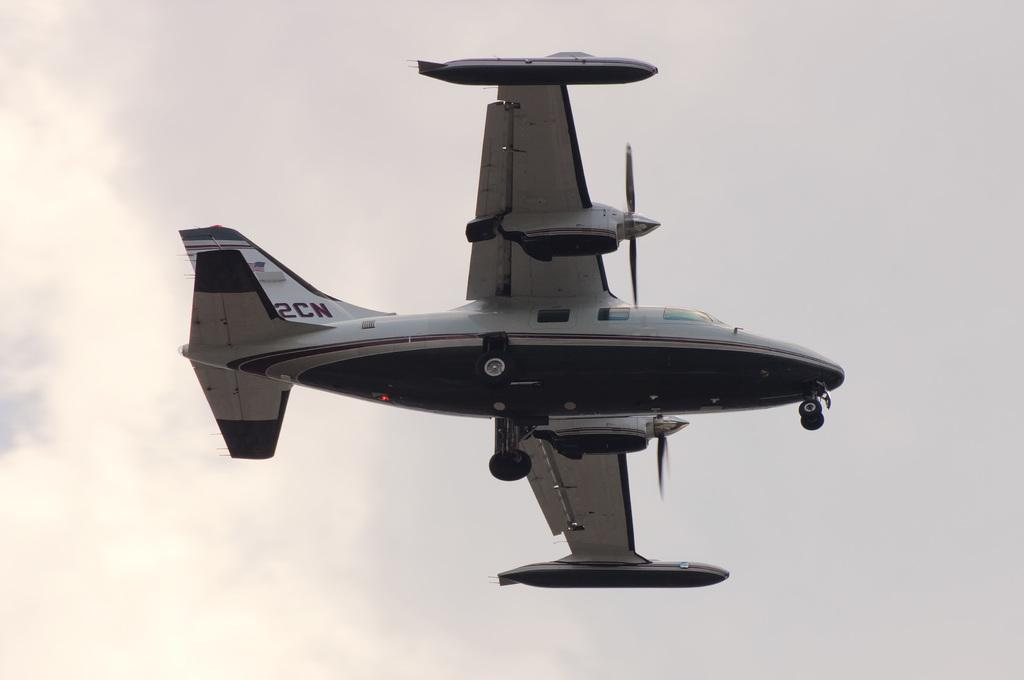What is the main subject of the image? The main subject of the image is an aircraft. What is the aircraft doing in the image? The aircraft is flying in the image. Where is the aircraft located in the image? The aircraft is in the sky in the image. What else can be seen in the sky in the image? There are clouds in the sky in the image. What type of food is the aircraft eating in the image? There is no food present in the image, and aircraft do not eat food. Is the aircraft reading a book while flying in the image? There is no book or indication of reading in the image, and aircraft do not read books. 